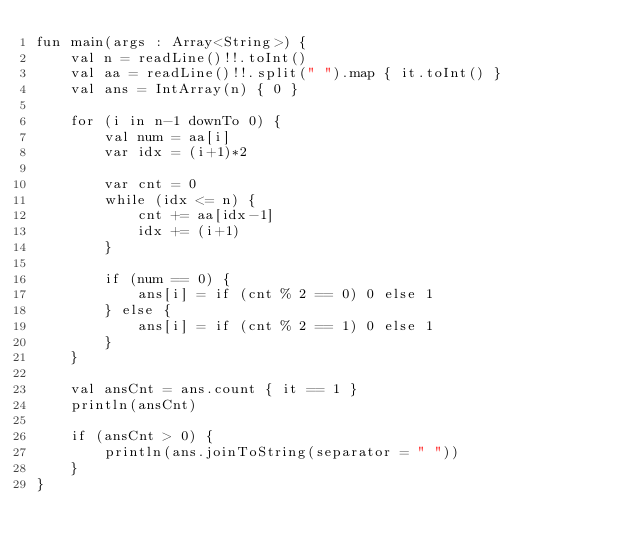<code> <loc_0><loc_0><loc_500><loc_500><_Kotlin_>fun main(args : Array<String>) {
    val n = readLine()!!.toInt()
    val aa = readLine()!!.split(" ").map { it.toInt() }
    val ans = IntArray(n) { 0 }

    for (i in n-1 downTo 0) {
        val num = aa[i]
        var idx = (i+1)*2

        var cnt = 0
        while (idx <= n) {
            cnt += aa[idx-1]
            idx += (i+1)
        }

        if (num == 0) {
            ans[i] = if (cnt % 2 == 0) 0 else 1
        } else {
            ans[i] = if (cnt % 2 == 1) 0 else 1
        }
    }

    val ansCnt = ans.count { it == 1 }
    println(ansCnt)

    if (ansCnt > 0) {
        println(ans.joinToString(separator = " "))
    }
}</code> 